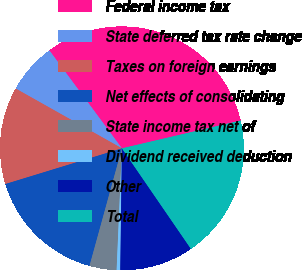<chart> <loc_0><loc_0><loc_500><loc_500><pie_chart><fcel>Federal income tax<fcel>State deferred tax rate change<fcel>Taxes on foreign earnings<fcel>Net effects of consolidating<fcel>State income tax net of<fcel>Dividend received deduction<fcel>Other<fcel>Total<nl><fcel>31.49%<fcel>6.69%<fcel>12.89%<fcel>15.99%<fcel>3.59%<fcel>0.48%<fcel>9.79%<fcel>19.09%<nl></chart> 